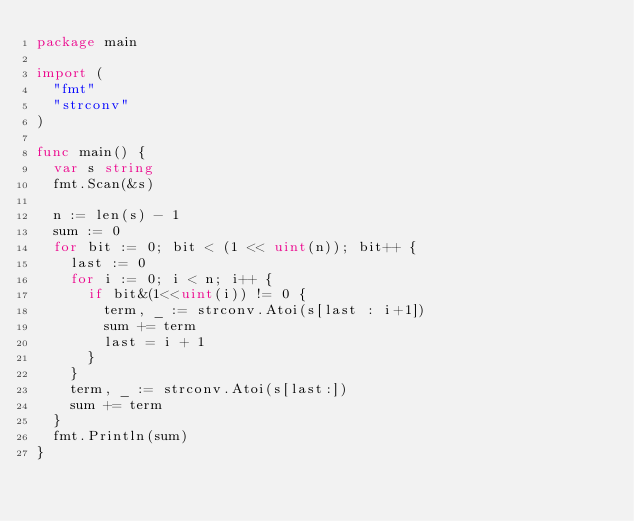<code> <loc_0><loc_0><loc_500><loc_500><_Go_>package main

import (
	"fmt"
	"strconv"
)

func main() {
	var s string
	fmt.Scan(&s)

	n := len(s) - 1
	sum := 0
	for bit := 0; bit < (1 << uint(n)); bit++ {
		last := 0
		for i := 0; i < n; i++ {
			if bit&(1<<uint(i)) != 0 {
				term, _ := strconv.Atoi(s[last : i+1])
				sum += term
				last = i + 1
			}
		}
		term, _ := strconv.Atoi(s[last:])
		sum += term
	}
	fmt.Println(sum)
}
</code> 